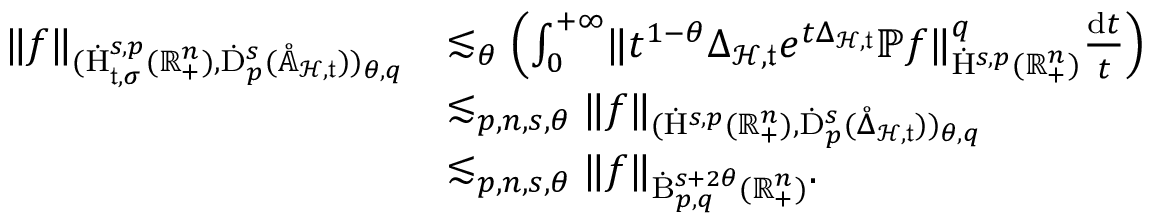<formula> <loc_0><loc_0><loc_500><loc_500>\begin{array} { r l } { \| f \| _ { ( \dot { H } _ { \mathfrak { t } , \sigma } ^ { s , p } ( \mathbb { R } _ { + } ^ { n } ) , \dot { D } _ { p } ^ { s } ( \mathring { \mathbb { A } } _ { \mathcal { H } , \mathfrak { t } } ) ) _ { \theta , q } } } & { \lesssim _ { \theta } \left ( \int _ { 0 } ^ { + \infty } \| t ^ { 1 - \theta } \Delta _ { \mathcal { H } , \mathfrak { t } } e ^ { t \Delta _ { \mathcal { H } , \mathfrak { t } } } \mathbb { P } f \| _ { \dot { H } ^ { s , p } ( \mathbb { R } _ { + } ^ { n } ) } ^ { q } \frac { d t } { t } \right ) } \\ & { \lesssim _ { p , n , s , \theta } \| f \| _ { ( \dot { H } ^ { s , p } ( \mathbb { R } _ { + } ^ { n } ) , \dot { D } _ { p } ^ { s } ( \mathring { \Delta } _ { \mathcal { H } , \mathfrak { t } } ) ) _ { \theta , q } } } \\ & { \lesssim _ { p , n , s , \theta } \| f \| _ { \dot { B } _ { p , q } ^ { s + 2 \theta } ( \mathbb { R } _ { + } ^ { n } ) } . } \end{array}</formula> 